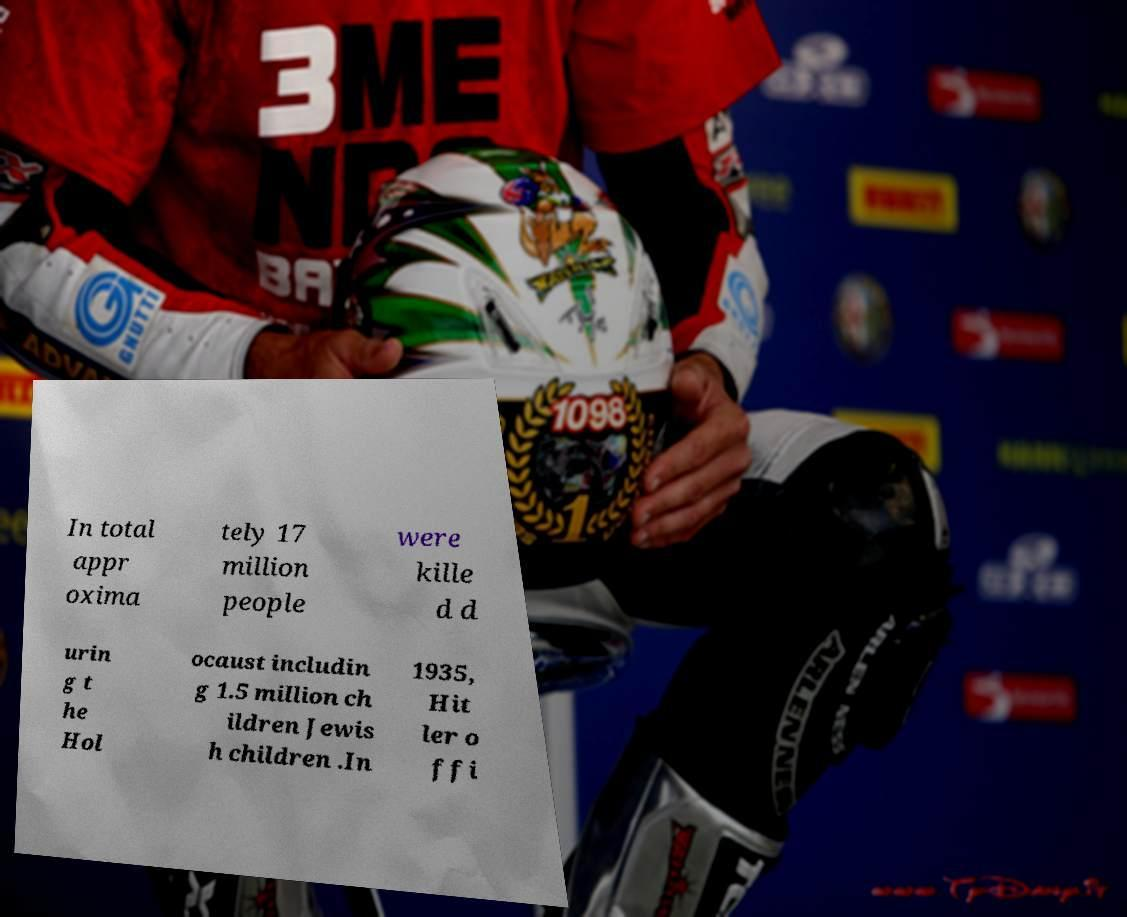Please read and relay the text visible in this image. What does it say? In total appr oxima tely 17 million people were kille d d urin g t he Hol ocaust includin g 1.5 million ch ildren Jewis h children .In 1935, Hit ler o ffi 